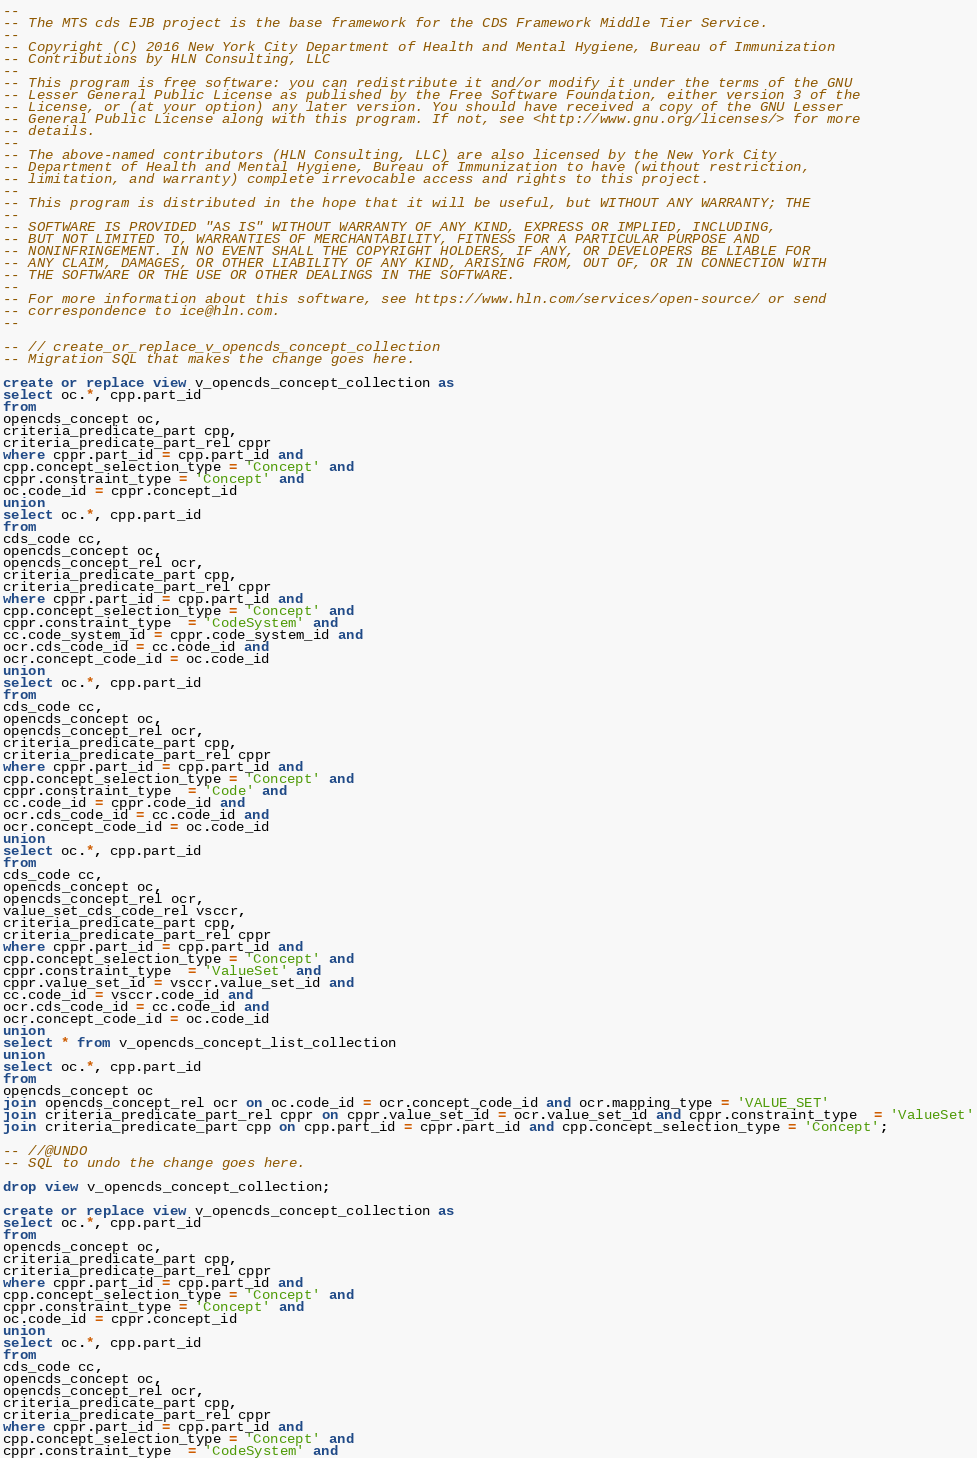Convert code to text. <code><loc_0><loc_0><loc_500><loc_500><_SQL_>--
-- The MTS cds EJB project is the base framework for the CDS Framework Middle Tier Service.
--
-- Copyright (C) 2016 New York City Department of Health and Mental Hygiene, Bureau of Immunization
-- Contributions by HLN Consulting, LLC
--
-- This program is free software: you can redistribute it and/or modify it under the terms of the GNU
-- Lesser General Public License as published by the Free Software Foundation, either version 3 of the
-- License, or (at your option) any later version. You should have received a copy of the GNU Lesser
-- General Public License along with this program. If not, see <http://www.gnu.org/licenses/> for more
-- details.
--
-- The above-named contributors (HLN Consulting, LLC) are also licensed by the New York City
-- Department of Health and Mental Hygiene, Bureau of Immunization to have (without restriction,
-- limitation, and warranty) complete irrevocable access and rights to this project.
--
-- This program is distributed in the hope that it will be useful, but WITHOUT ANY WARRANTY; THE
--
-- SOFTWARE IS PROVIDED "AS IS" WITHOUT WARRANTY OF ANY KIND, EXPRESS OR IMPLIED, INCLUDING,
-- BUT NOT LIMITED TO, WARRANTIES OF MERCHANTABILITY, FITNESS FOR A PARTICULAR PURPOSE AND
-- NONINFRINGEMENT. IN NO EVENT SHALL THE COPYRIGHT HOLDERS, IF ANY, OR DEVELOPERS BE LIABLE FOR
-- ANY CLAIM, DAMAGES, OR OTHER LIABILITY OF ANY KIND, ARISING FROM, OUT OF, OR IN CONNECTION WITH
-- THE SOFTWARE OR THE USE OR OTHER DEALINGS IN THE SOFTWARE.
--
-- For more information about this software, see https://www.hln.com/services/open-source/ or send
-- correspondence to ice@hln.com.
--

-- // create_or_replace_v_opencds_concept_collection
-- Migration SQL that makes the change goes here.

create or replace view v_opencds_concept_collection as
select oc.*, cpp.part_id
from 
opencds_concept oc,
criteria_predicate_part cpp, 
criteria_predicate_part_rel cppr
where cppr.part_id = cpp.part_id and
cpp.concept_selection_type = 'Concept' and
cppr.constraint_type = 'Concept' and
oc.code_id = cppr.concept_id
union
select oc.*, cpp.part_id
from 
cds_code cc,
opencds_concept oc,
opencds_concept_rel ocr,
criteria_predicate_part cpp, 
criteria_predicate_part_rel cppr
where cppr.part_id = cpp.part_id and
cpp.concept_selection_type = 'Concept' and
cppr.constraint_type  = 'CodeSystem' and
cc.code_system_id = cppr.code_system_id and
ocr.cds_code_id = cc.code_id and
ocr.concept_code_id = oc.code_id
union
select oc.*, cpp.part_id
from 
cds_code cc,
opencds_concept oc,
opencds_concept_rel ocr,
criteria_predicate_part cpp, 
criteria_predicate_part_rel cppr
where cppr.part_id = cpp.part_id and
cpp.concept_selection_type = 'Concept' and
cppr.constraint_type  = 'Code' and
cc.code_id = cppr.code_id and
ocr.cds_code_id = cc.code_id and
ocr.concept_code_id = oc.code_id
union
select oc.*, cpp.part_id
from 
cds_code cc,
opencds_concept oc,
opencds_concept_rel ocr,
value_set_cds_code_rel vsccr,
criteria_predicate_part cpp, 
criteria_predicate_part_rel cppr
where cppr.part_id = cpp.part_id and
cpp.concept_selection_type = 'Concept' and
cppr.constraint_type  = 'ValueSet' and
cppr.value_set_id = vsccr.value_set_id and
cc.code_id = vsccr.code_id and
ocr.cds_code_id = cc.code_id and
ocr.concept_code_id = oc.code_id
union
select * from v_opencds_concept_list_collection
union
select oc.*, cpp.part_id
from 
opencds_concept oc
join opencds_concept_rel ocr on oc.code_id = ocr.concept_code_id and ocr.mapping_type = 'VALUE_SET'
join criteria_predicate_part_rel cppr on cppr.value_set_id = ocr.value_set_id and cppr.constraint_type  = 'ValueSet'
join criteria_predicate_part cpp on cpp.part_id = cppr.part_id and cpp.concept_selection_type = 'Concept';

-- //@UNDO
-- SQL to undo the change goes here.

drop view v_opencds_concept_collection;

create or replace view v_opencds_concept_collection as
select oc.*, cpp.part_id
from 
opencds_concept oc,
criteria_predicate_part cpp, 
criteria_predicate_part_rel cppr
where cppr.part_id = cpp.part_id and
cpp.concept_selection_type = 'Concept' and
cppr.constraint_type = 'Concept' and
oc.code_id = cppr.concept_id
union
select oc.*, cpp.part_id
from 
cds_code cc,
opencds_concept oc,
opencds_concept_rel ocr,
criteria_predicate_part cpp, 
criteria_predicate_part_rel cppr
where cppr.part_id = cpp.part_id and
cpp.concept_selection_type = 'Concept' and
cppr.constraint_type  = 'CodeSystem' and</code> 